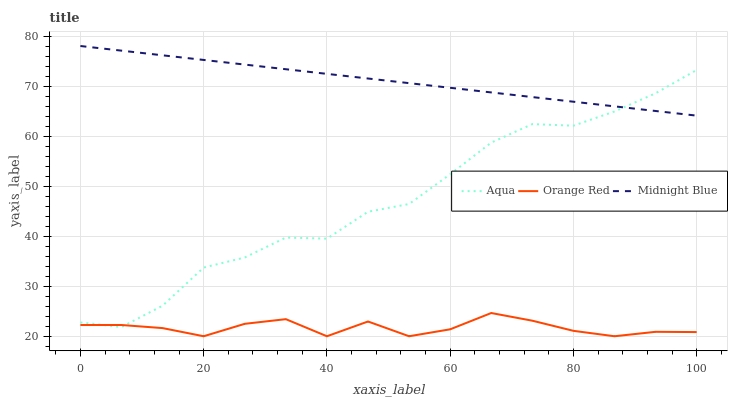Does Orange Red have the minimum area under the curve?
Answer yes or no. Yes. Does Midnight Blue have the maximum area under the curve?
Answer yes or no. Yes. Does Midnight Blue have the minimum area under the curve?
Answer yes or no. No. Does Orange Red have the maximum area under the curve?
Answer yes or no. No. Is Midnight Blue the smoothest?
Answer yes or no. Yes. Is Aqua the roughest?
Answer yes or no. Yes. Is Orange Red the smoothest?
Answer yes or no. No. Is Orange Red the roughest?
Answer yes or no. No. Does Orange Red have the lowest value?
Answer yes or no. Yes. Does Midnight Blue have the lowest value?
Answer yes or no. No. Does Midnight Blue have the highest value?
Answer yes or no. Yes. Does Orange Red have the highest value?
Answer yes or no. No. Is Orange Red less than Midnight Blue?
Answer yes or no. Yes. Is Midnight Blue greater than Orange Red?
Answer yes or no. Yes. Does Aqua intersect Orange Red?
Answer yes or no. Yes. Is Aqua less than Orange Red?
Answer yes or no. No. Is Aqua greater than Orange Red?
Answer yes or no. No. Does Orange Red intersect Midnight Blue?
Answer yes or no. No. 